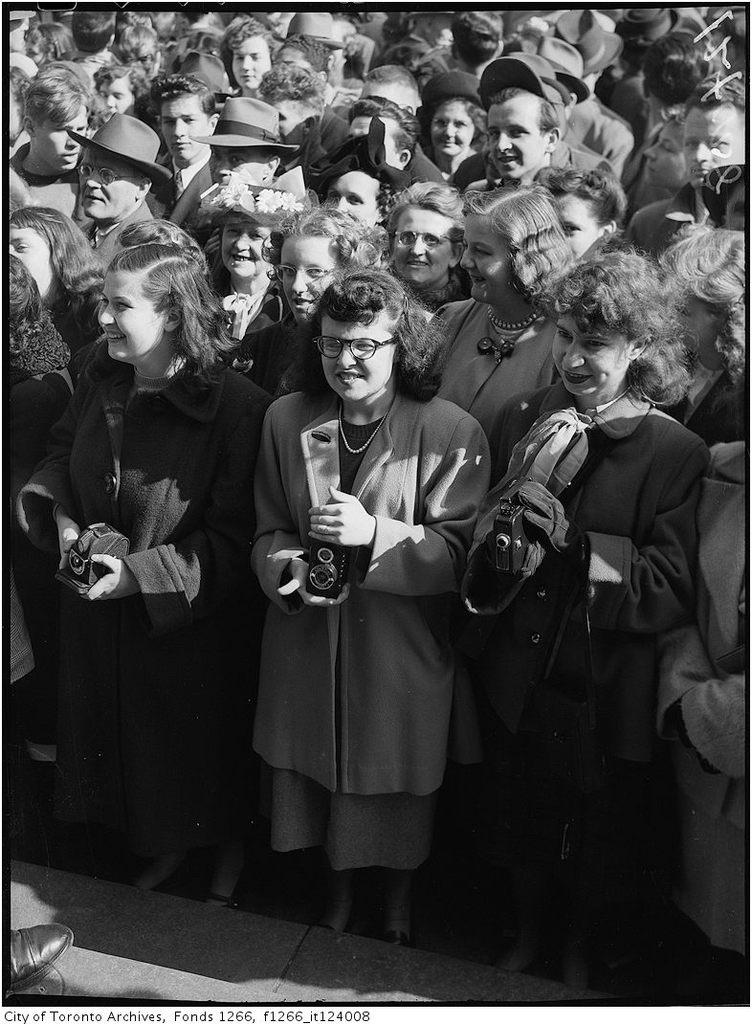What is the main subject of the image? The main subject of the image is a crowd. Can you describe any specific objects or details in the image? Yes, there is a shoe visible at the bottom of the image, and there is text visible as well. How many women are in the foreground of the image? There are three women in the foreground of the image. What are the women holding? The women are holding cameras. What is the tax rate for the nation depicted in the image? There is no nation depicted in the image, so it is not possible to determine the tax rate. 